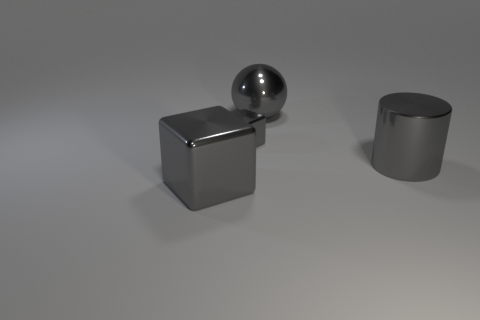Add 2 big objects. How many objects exist? 6 Subtract all spheres. How many objects are left? 3 Add 4 balls. How many balls exist? 5 Subtract 0 blue spheres. How many objects are left? 4 Subtract all blue spheres. Subtract all red cylinders. How many spheres are left? 1 Subtract all gray shiny spheres. Subtract all small gray metal blocks. How many objects are left? 2 Add 3 spheres. How many spheres are left? 4 